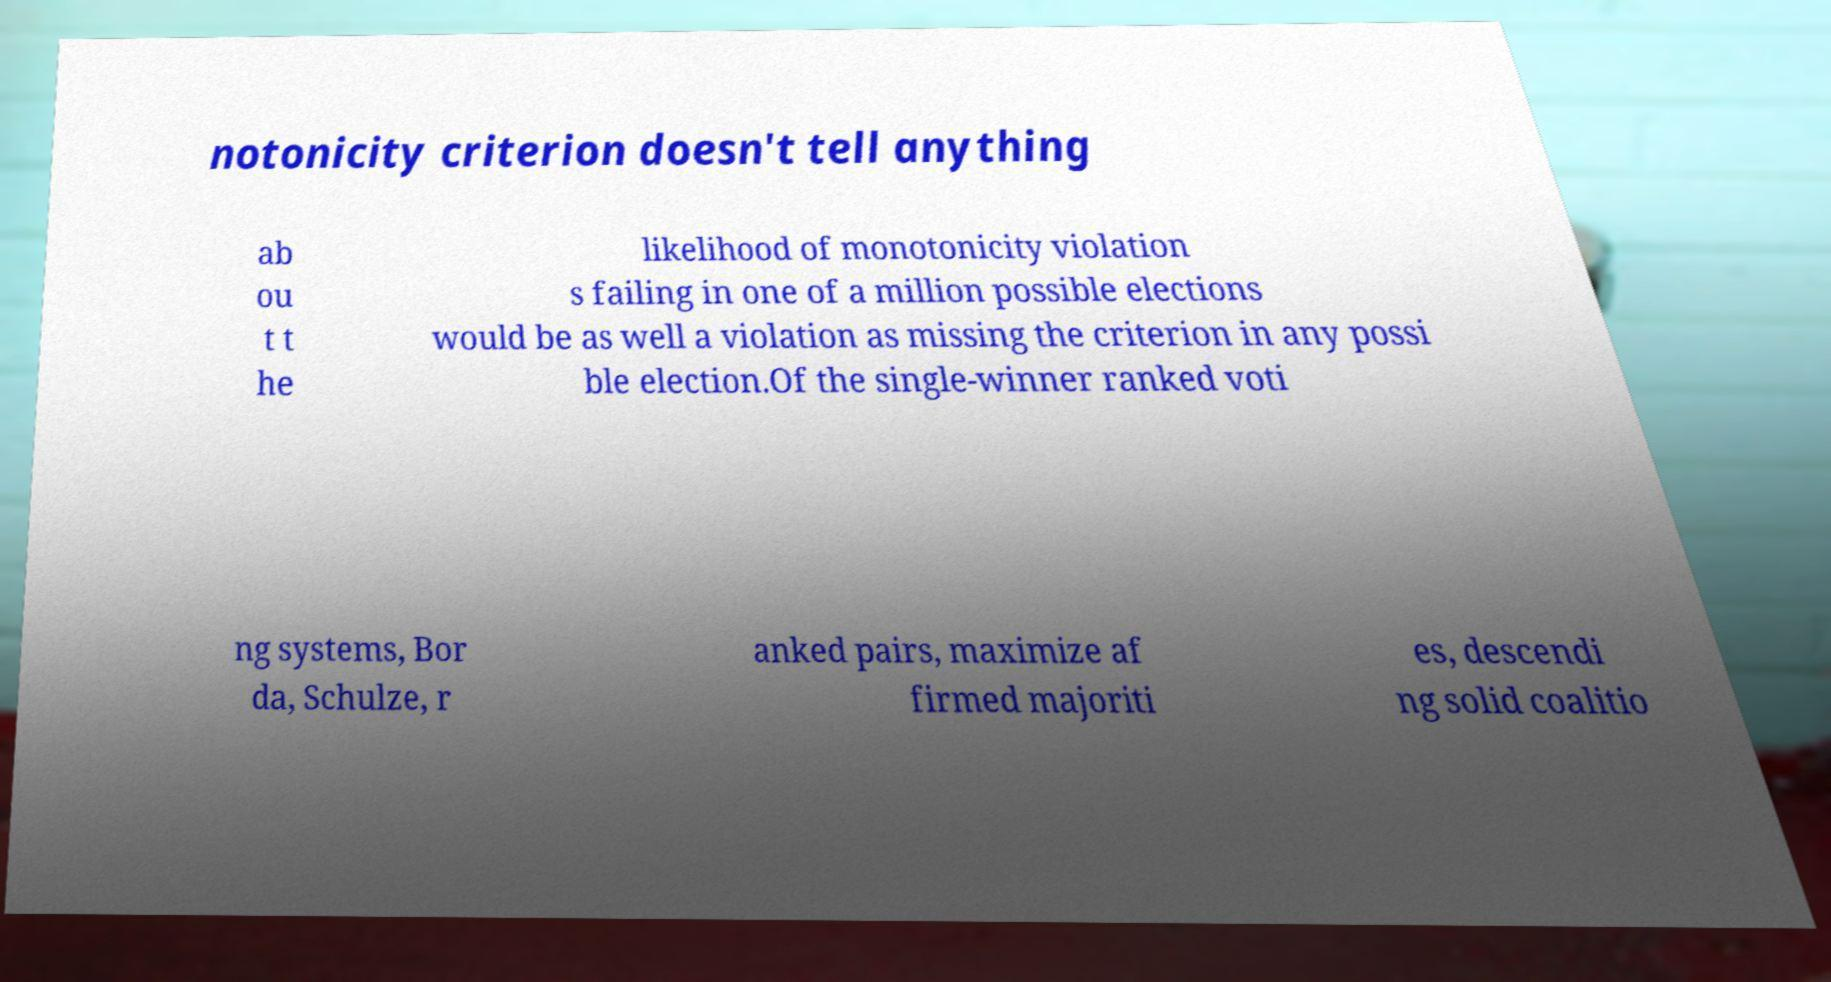Please identify and transcribe the text found in this image. notonicity criterion doesn't tell anything ab ou t t he likelihood of monotonicity violation s failing in one of a million possible elections would be as well a violation as missing the criterion in any possi ble election.Of the single-winner ranked voti ng systems, Bor da, Schulze, r anked pairs, maximize af firmed majoriti es, descendi ng solid coalitio 